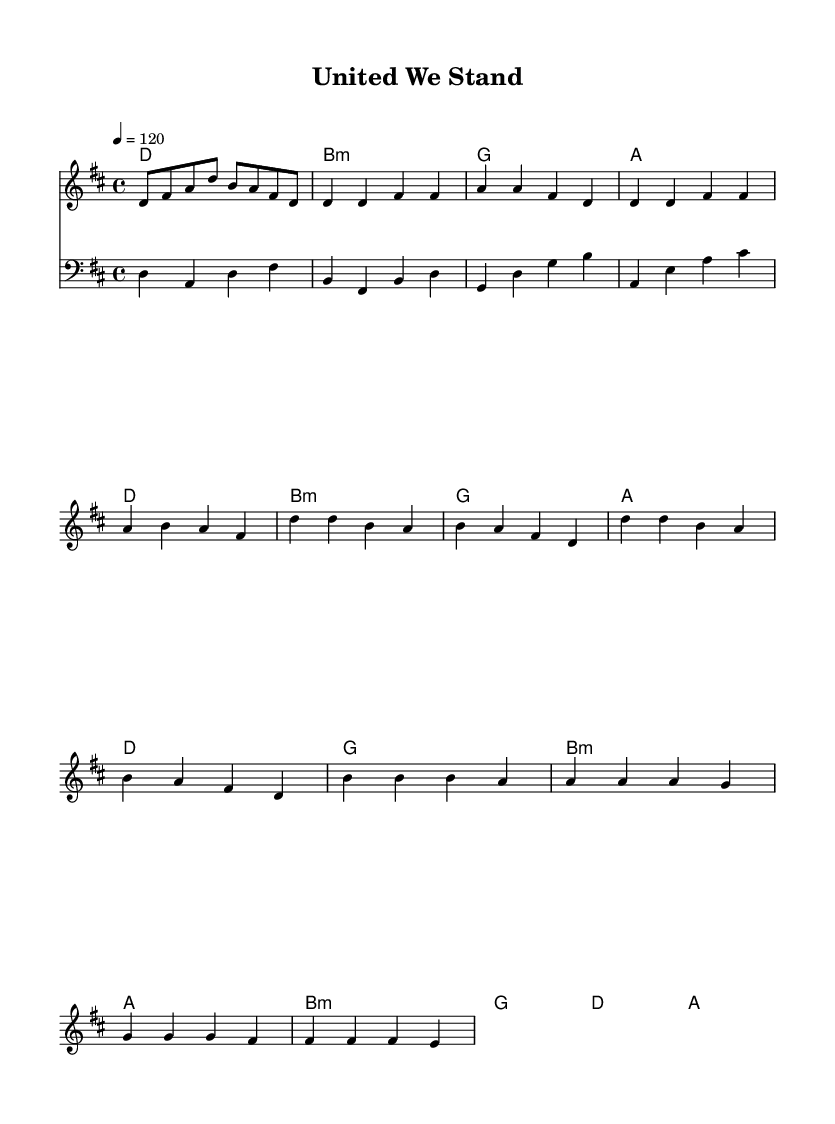What is the key signature of this music? The key signature is D major, which has two sharps (F# and C#), as indicated at the beginning of the sheet music.
Answer: D major What is the time signature of this music? The time signature is 4/4, meaning there are four beats in each measure, as specified at the start of the piece.
Answer: 4/4 What is the tempo marking of this piece? The tempo marking is quarter note = 120, indicating the speed at which the piece should be played, as found in the global settings.
Answer: 120 How many measures are in the verse section? The verse consists of four measures, visible when analyzing the notation used in the verse section of the sheet music.
Answer: 4 Which chords are used in the chorus? The chorus uses D, G, B minor, and A chords, as seen in the harmonious section that accompanies the chorus.
Answer: D, G, B minor, A What is the last note of the bridge? The last note of the bridge is an A, which appears at the end of the bridge section in the melody line provided.
Answer: A What style of music does this sheet represent? This sheet represents a pop style, characterized by its upbeat tempo and thematic focus on community and engagement, as inferred from the title and content.
Answer: Pop 